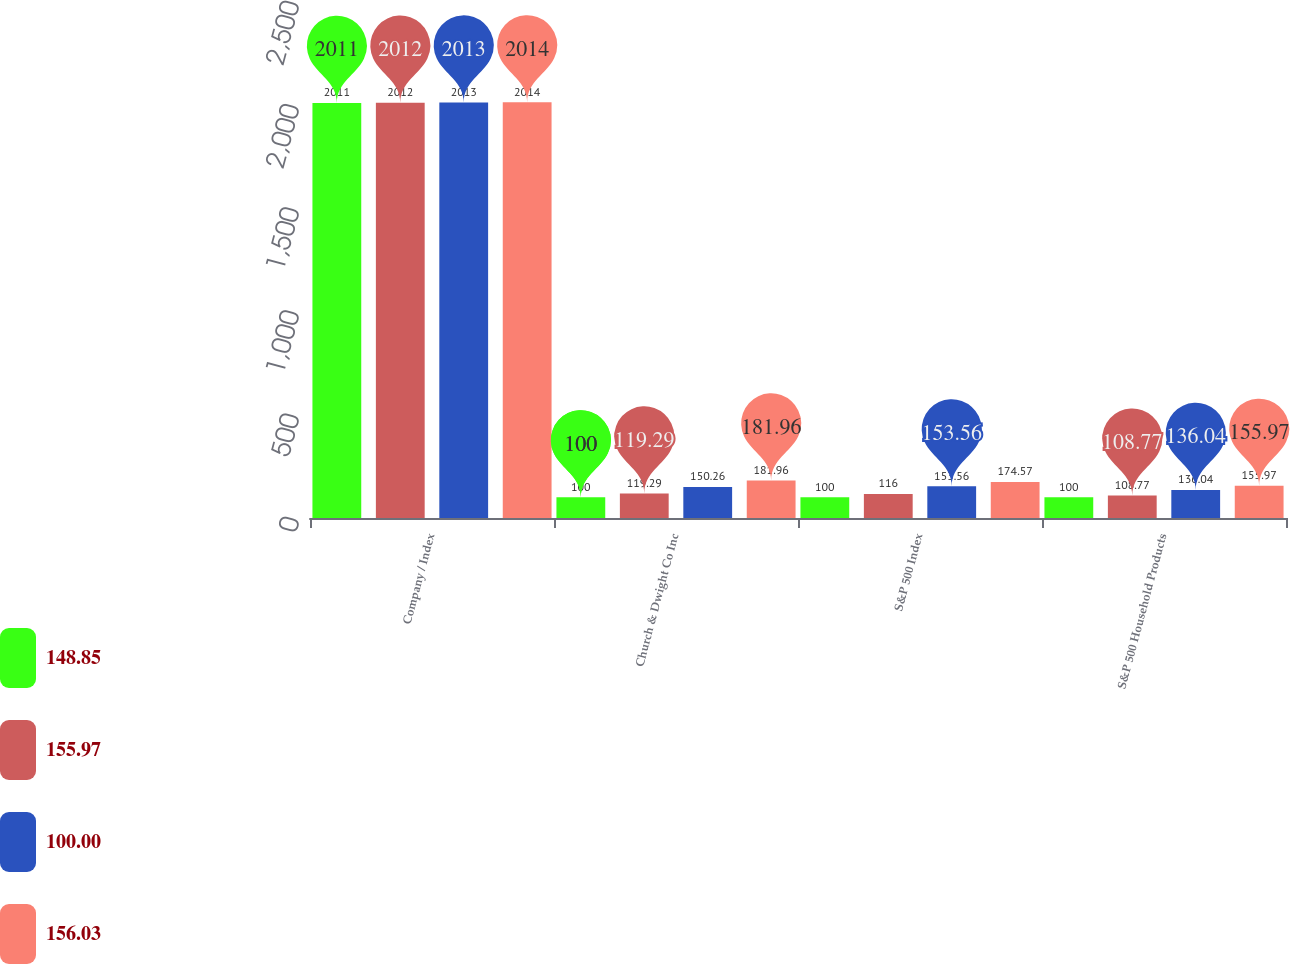Convert chart. <chart><loc_0><loc_0><loc_500><loc_500><stacked_bar_chart><ecel><fcel>Company / Index<fcel>Church & Dwight Co Inc<fcel>S&P 500 Index<fcel>S&P 500 Household Products<nl><fcel>148.85<fcel>2011<fcel>100<fcel>100<fcel>100<nl><fcel>155.97<fcel>2012<fcel>119.29<fcel>116<fcel>108.77<nl><fcel>100<fcel>2013<fcel>150.26<fcel>153.56<fcel>136.04<nl><fcel>156.03<fcel>2014<fcel>181.96<fcel>174.57<fcel>155.97<nl></chart> 